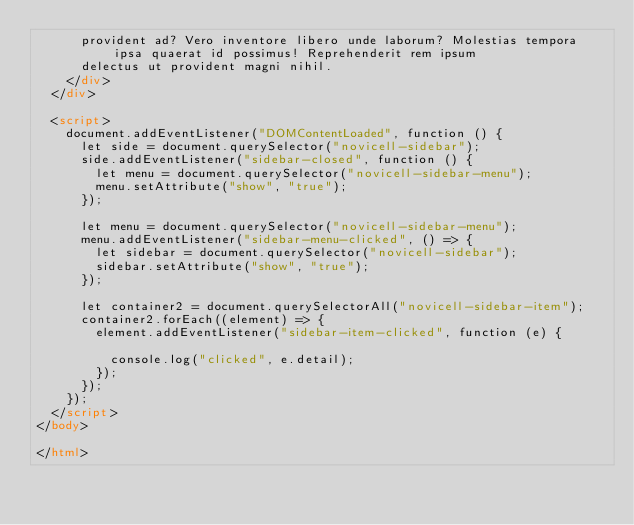Convert code to text. <code><loc_0><loc_0><loc_500><loc_500><_HTML_>      provident ad? Vero inventore libero unde laborum? Molestias tempora ipsa quaerat id possimus! Reprehenderit rem ipsum
      delectus ut provident magni nihil.
    </div>
  </div>

  <script>
    document.addEventListener("DOMContentLoaded", function () {
      let side = document.querySelector("novicell-sidebar");
      side.addEventListener("sidebar-closed", function () {
        let menu = document.querySelector("novicell-sidebar-menu");
        menu.setAttribute("show", "true");
      });

      let menu = document.querySelector("novicell-sidebar-menu");
      menu.addEventListener("sidebar-menu-clicked", () => {
        let sidebar = document.querySelector("novicell-sidebar");
        sidebar.setAttribute("show", "true");
      });

      let container2 = document.querySelectorAll("novicell-sidebar-item");
      container2.forEach((element) => {
        element.addEventListener("sidebar-item-clicked", function (e) {

          console.log("clicked", e.detail);
        });
      });
    });
  </script>
</body>

</html></code> 